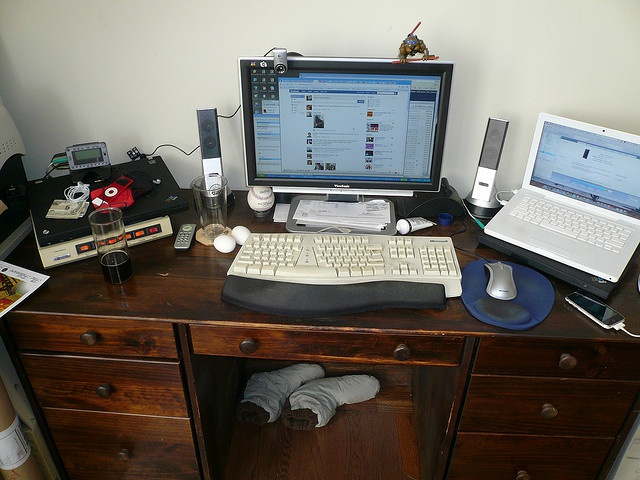Describe the objects in this image and their specific colors. I can see tv in gray, darkgray, and black tones, laptop in gray, lightgray, lightblue, and black tones, keyboard in gray, beige, darkgray, and tan tones, cup in gray, black, tan, and darkgreen tones, and keyboard in gray, lightgray, and darkgray tones in this image. 